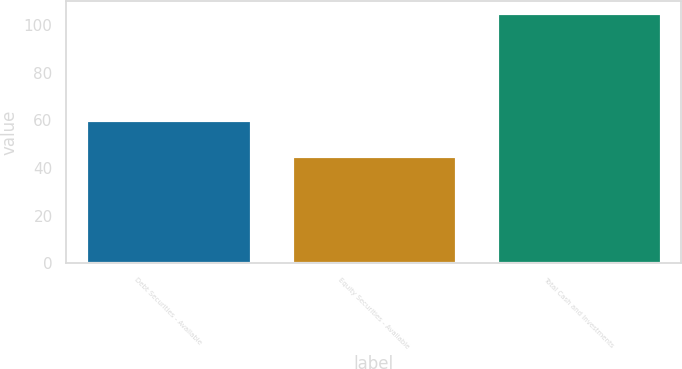<chart> <loc_0><loc_0><loc_500><loc_500><bar_chart><fcel>Debt Securities - Available<fcel>Equity Securities - Available<fcel>Total Cash and Investments<nl><fcel>60<fcel>45<fcel>105<nl></chart> 